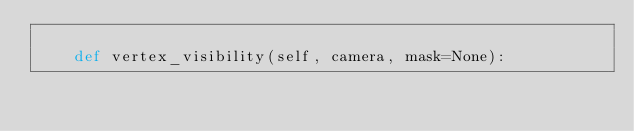<code> <loc_0><loc_0><loc_500><loc_500><_Python_>
    def vertex_visibility(self, camera, mask=None):</code> 